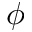Convert formula to latex. <formula><loc_0><loc_0><loc_500><loc_500>\phi</formula> 